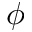Convert formula to latex. <formula><loc_0><loc_0><loc_500><loc_500>\phi</formula> 